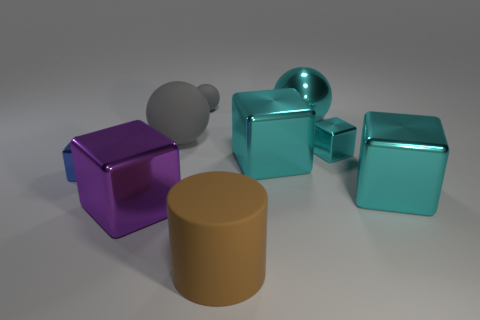How does the texture of the metallic objects compare to the matte cylinder? The metallic objects have a glossy finish that reflects light, giving them a shiny appearance, while the matte cylinder has a non-reflective surface that diffuses light, resulting in a flat, uniform look. 